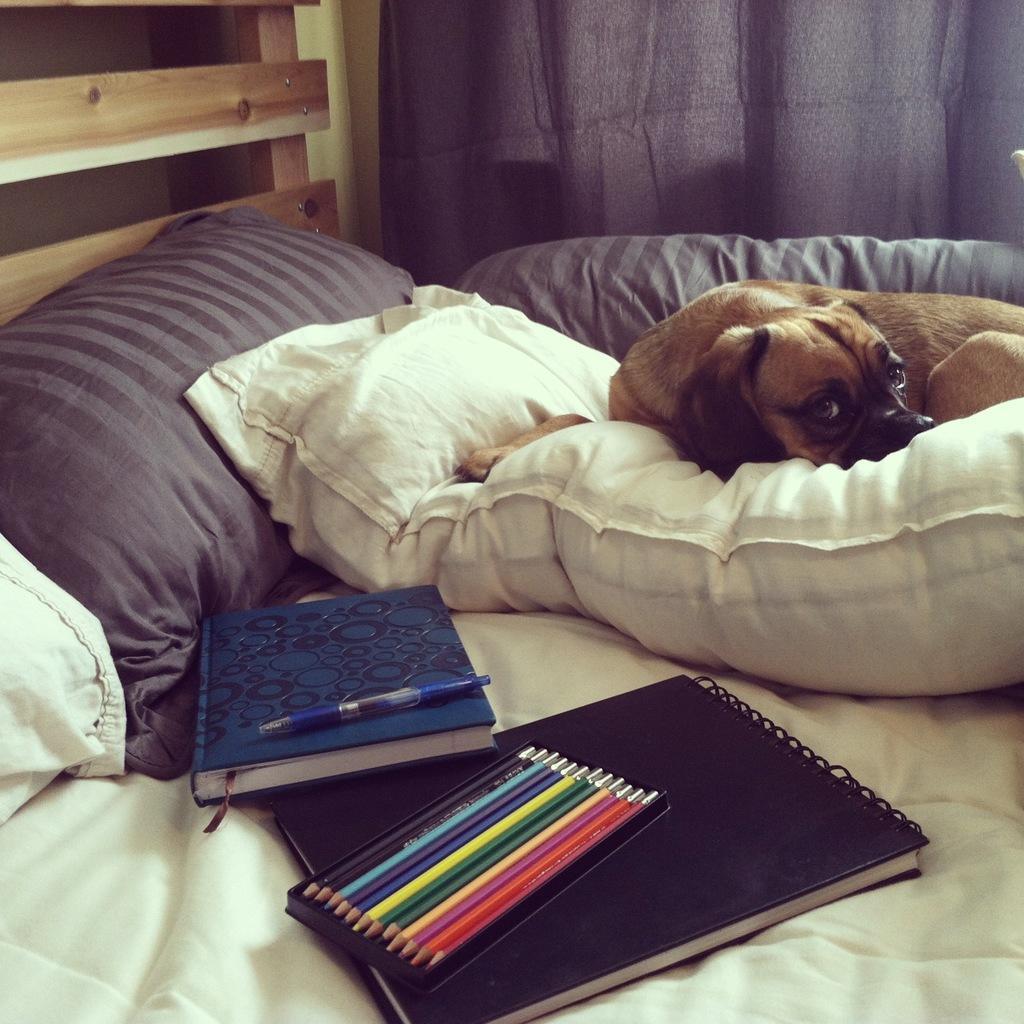Can you describe this image briefly? On the bed there are pillows,books,pencils and a pen and a dog is on the pillow. In the background there is a wall and curtain. 